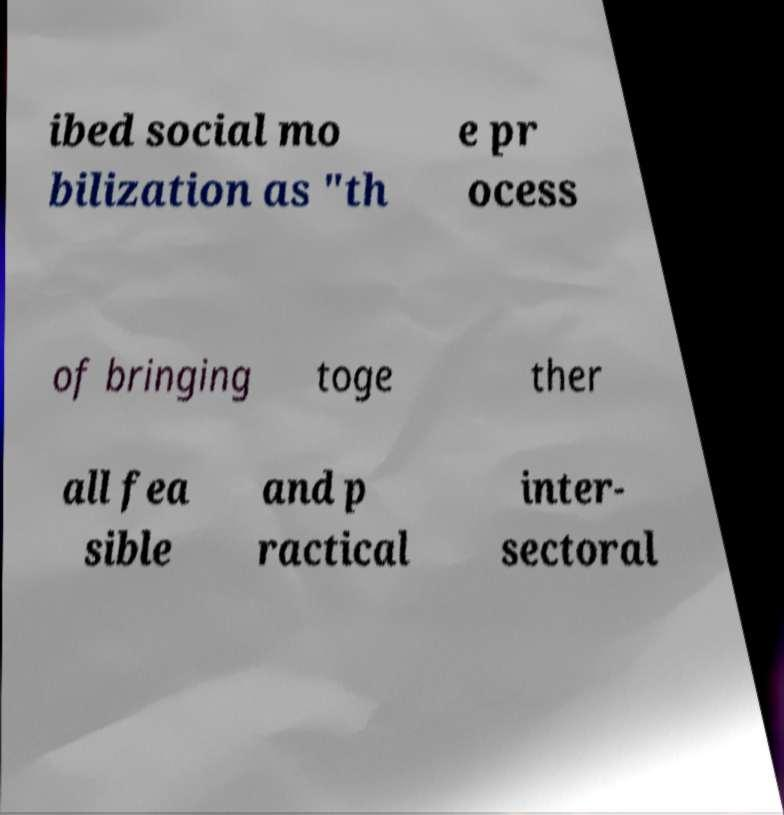What messages or text are displayed in this image? I need them in a readable, typed format. ibed social mo bilization as "th e pr ocess of bringing toge ther all fea sible and p ractical inter- sectoral 